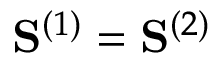Convert formula to latex. <formula><loc_0><loc_0><loc_500><loc_500>S ^ { ( 1 ) } = S ^ { ( 2 ) }</formula> 